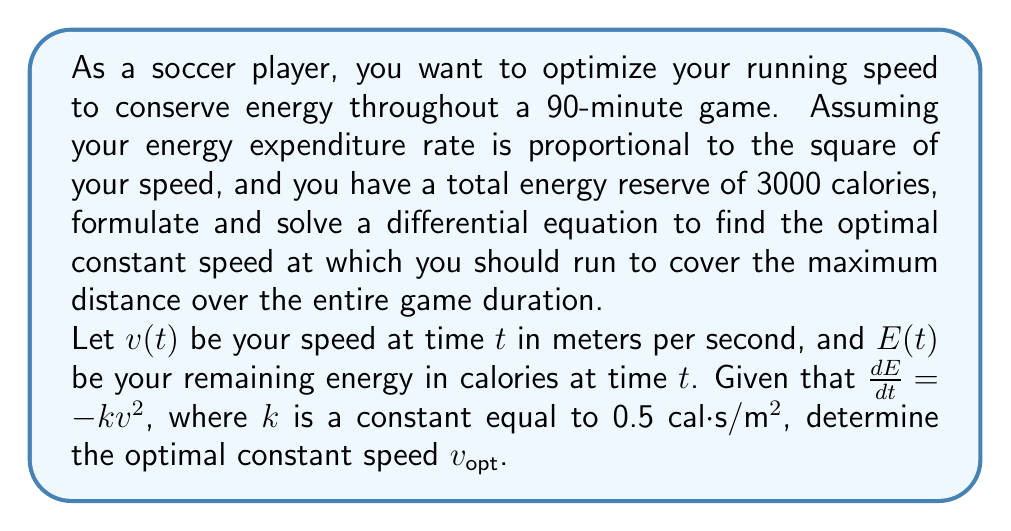Can you answer this question? To solve this problem, we'll follow these steps:

1) First, let's set up our differential equation:

   $$\frac{dE}{dt} = -kv^2$$

   Where $k = 0.5$ cal⋅s/m²

2) We want to maximize the total distance covered. Distance is the integral of velocity over time:

   $$D = \int_0^T v(t) dt$$

   Where $T$ is the total time (90 minutes = 5400 seconds)

3) If we're running at a constant speed $v$, then:

   $$D = vT$$

4) Now, let's relate this to our energy equation. We start with 3000 calories and end with 0:

   $$\int_0^T \frac{dE}{dt} dt = -3000$$

5) Substituting our differential equation:

   $$\int_0^T -kv^2 dt = -3000$$

6) Solving this integral:

   $$-kv^2T = -3000$$

7) Solving for $v$:

   $$v = \sqrt{\frac{3000}{kT}}$$

8) Now we can substitute our known values:

   $$v_{opt} = \sqrt{\frac{3000}{0.5 \cdot 5400}} = \sqrt{\frac{10}{9}} \approx 1.054 \text{ m/s}$$

This is the optimal constant speed to run throughout the game to maximize total distance covered while using exactly all available energy.
Answer: The optimal constant running speed is $v_{opt} = \sqrt{\frac{10}{9}} \approx 1.054 \text{ m/s}$ or about 3.79 km/h. 